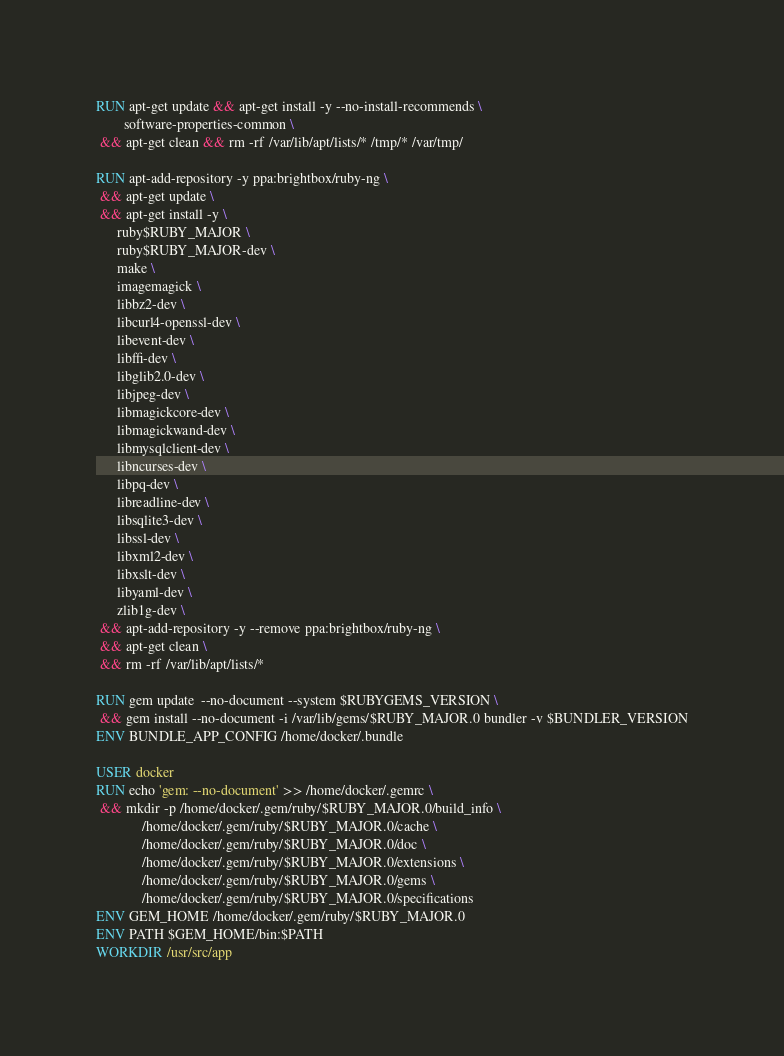Convert code to text. <code><loc_0><loc_0><loc_500><loc_500><_Dockerfile_>
RUN apt-get update && apt-get install -y --no-install-recommends \
        software-properties-common \
 && apt-get clean && rm -rf /var/lib/apt/lists/* /tmp/* /var/tmp/

RUN apt-add-repository -y ppa:brightbox/ruby-ng \
 && apt-get update \
 && apt-get install -y \
      ruby$RUBY_MAJOR \
      ruby$RUBY_MAJOR-dev \
      make \
      imagemagick \
      libbz2-dev \
      libcurl4-openssl-dev \
      libevent-dev \
      libffi-dev \
      libglib2.0-dev \
      libjpeg-dev \
      libmagickcore-dev \
      libmagickwand-dev \
      libmysqlclient-dev \
      libncurses-dev \
      libpq-dev \
      libreadline-dev \
      libsqlite3-dev \
      libssl-dev \
      libxml2-dev \
      libxslt-dev \
      libyaml-dev \
      zlib1g-dev \
 && apt-add-repository -y --remove ppa:brightbox/ruby-ng \
 && apt-get clean \
 && rm -rf /var/lib/apt/lists/*

RUN gem update  --no-document --system $RUBYGEMS_VERSION \
 && gem install --no-document -i /var/lib/gems/$RUBY_MAJOR.0 bundler -v $BUNDLER_VERSION
ENV BUNDLE_APP_CONFIG /home/docker/.bundle

USER docker
RUN echo 'gem: --no-document' >> /home/docker/.gemrc \
 && mkdir -p /home/docker/.gem/ruby/$RUBY_MAJOR.0/build_info \
             /home/docker/.gem/ruby/$RUBY_MAJOR.0/cache \
             /home/docker/.gem/ruby/$RUBY_MAJOR.0/doc \
             /home/docker/.gem/ruby/$RUBY_MAJOR.0/extensions \
             /home/docker/.gem/ruby/$RUBY_MAJOR.0/gems \
             /home/docker/.gem/ruby/$RUBY_MAJOR.0/specifications
ENV GEM_HOME /home/docker/.gem/ruby/$RUBY_MAJOR.0
ENV PATH $GEM_HOME/bin:$PATH
WORKDIR /usr/src/app

</code> 